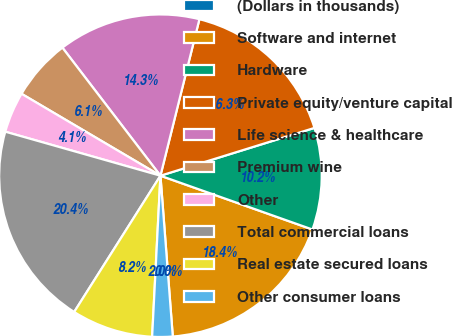<chart> <loc_0><loc_0><loc_500><loc_500><pie_chart><fcel>(Dollars in thousands)<fcel>Software and internet<fcel>Hardware<fcel>Private equity/venture capital<fcel>Life science & healthcare<fcel>Premium wine<fcel>Other<fcel>Total commercial loans<fcel>Real estate secured loans<fcel>Other consumer loans<nl><fcel>0.0%<fcel>18.36%<fcel>10.2%<fcel>16.32%<fcel>14.28%<fcel>6.12%<fcel>4.08%<fcel>20.41%<fcel>8.16%<fcel>2.04%<nl></chart> 